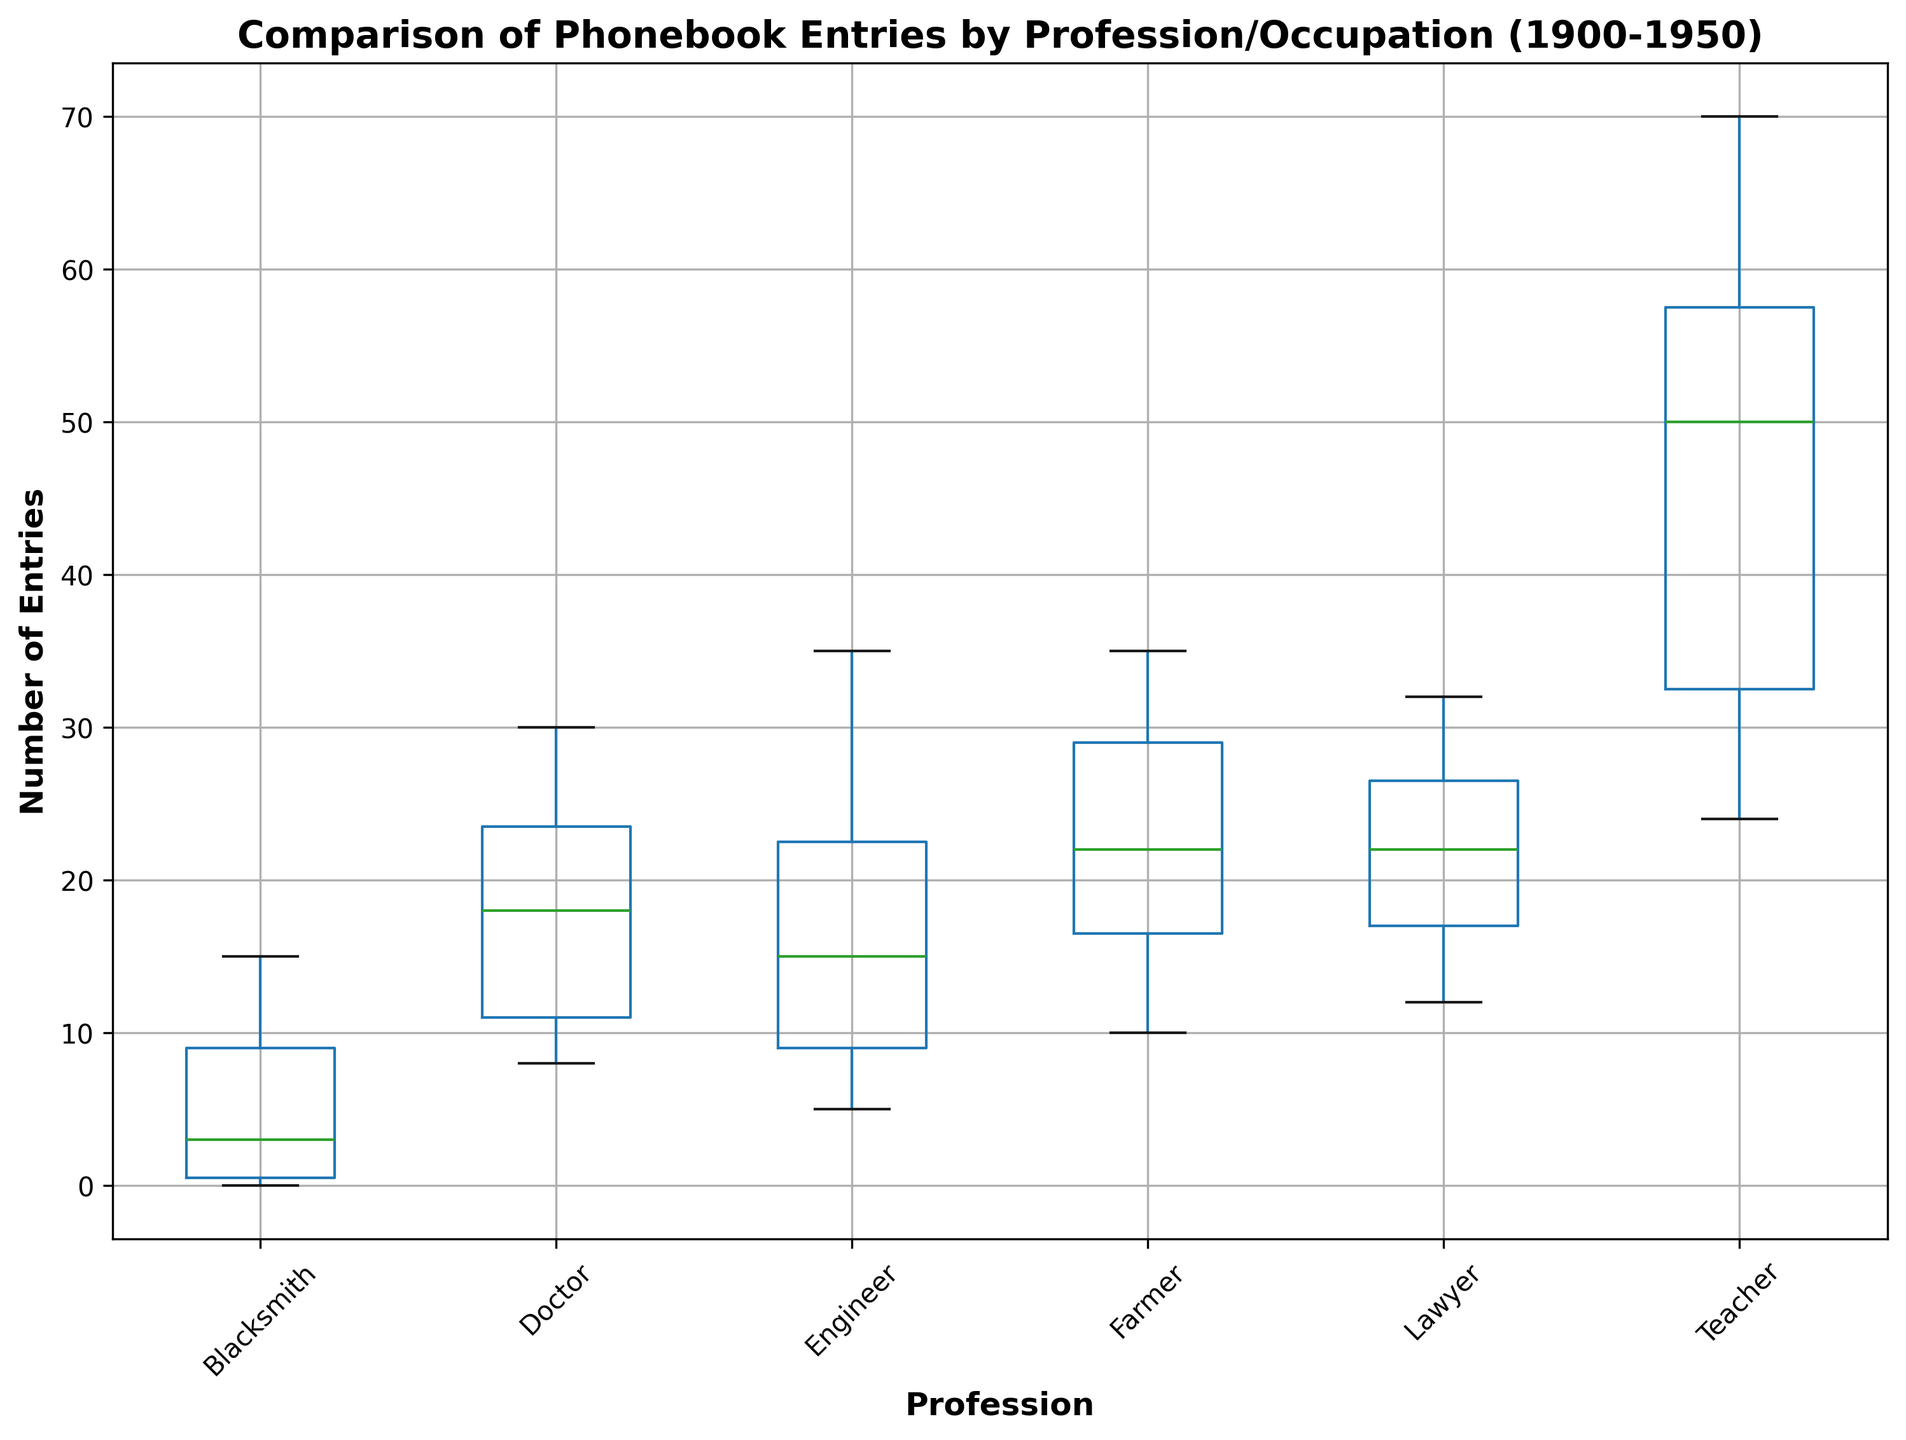What is the median number of phonebook entries for the Teacher profession? To find the median, look at the center value of the Teacher data distribution in the box plot. Since the Teacher entries likely span multiple years and are equally spread, the median should be around the middle of this range.
Answer: Approximately 50 Which profession has the highest median number of phonebook entries? Compare the central box (median line) along the y-axis for each profession in the box plot. The one with the highest median line will have the highest median number of entries.
Answer: Teacher How does the interquartile range (IQR) of phonebook entries for Engineers compare to that of Farmers? The IQR is represented by the height of the central box in the box plot. By visually comparing the heights of the boxes, you can see which profession has a larger or smaller spread.
Answer: Engineer has a larger IQR Which profession shows a decreasing trend in phonebook entries over the years? A decreasing trend will be visually represented by a downward slope in the box plot central values over time. Check the overall pattern for each profession's distribution in the box plot.
Answer: Blacksmith What is the range of phonebook entries for Lawyers? The range is represented by the distance between the minimum and maximum values (whiskers) in the box plot. Visually check the highest and lowest points of the lawyer's box plot.
Answer: Approximately 12 to 32 Between Doctors and Engineers, which profession has a higher maximum number of phonebook entries? The maximum value is the top whisker or the highest point for each profession in the box plot. Compare the highest points for Doctors and Engineers.
Answer: Engineer Which profession shows the most significant increase in phonebook entries over the years? Look for the profession where the central values (median) increase significantly over the time range represented in the box plot.
Answer: Engineer What is the median number of phonebook entries for Blacksmiths, and how does it compare to Farmers? To determine the median for both Blacksmiths and Farmers, compare the central value (line in the middle of the box) of each profession's box plot. Farmers' median should be higher compared to Blacksmiths'.
Answer: Blacksmiths 5, Farmers 22 Which profession's box plot has the smallest interquartile range (IQR)? The smallest IQR will be the smallest height of the box in the plot. Visually identify the box with the smallest vertical distance between its top and bottom.
Answer: Blacksmith 